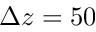Convert formula to latex. <formula><loc_0><loc_0><loc_500><loc_500>\Delta z = 5 0</formula> 